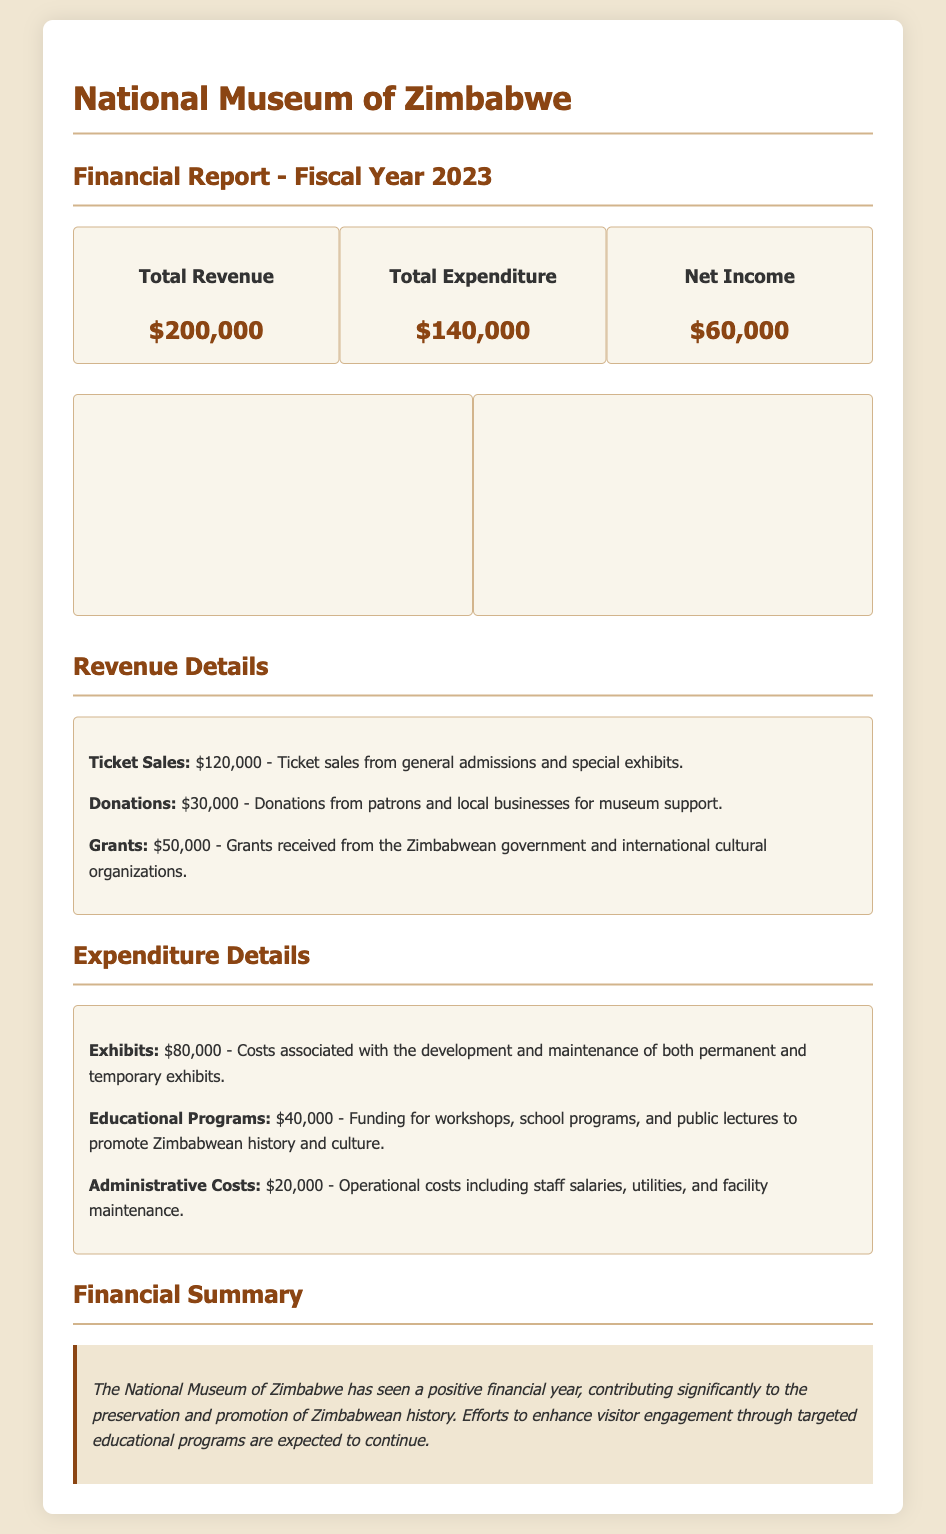what is the total revenue? The total revenue is displayed as the sum of all revenue sources in the financial summary, which is $200,000.
Answer: $200,000 what is the total expenditure? The total expenditure is shown in the financial summary as $140,000.
Answer: $140,000 what is the net income? The net income is calculated as total revenue minus total expenditure, which is $60,000.
Answer: $60,000 how much revenue came from ticket sales? The document specifies that ticket sales generated $120,000 in revenue.
Answer: $120,000 how much was spent on educational programs? The expenditure on educational programs is detailed as $40,000 in the financial report.
Answer: $40,000 what are the sources of revenue listed? The revenue sources listed include ticket sales, donations, and grants.
Answer: ticket sales, donations, grants what is the largest category of expenditure? The largest category of expenditure highlighted in the document is for exhibits, totaling $80,000.
Answer: exhibits how much was received in donations? Donations received, as noted in the revenue details, amount to $30,000.
Answer: $30,000 what percentage of total revenue comes from grants? Grants are stated as $50,000 out of total revenue of $200,000, equivalent to 25%.
Answer: 25% 